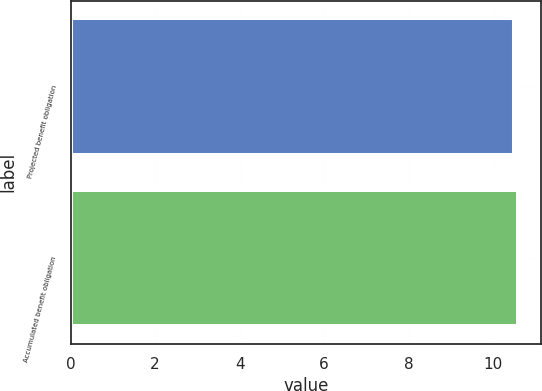Convert chart to OTSL. <chart><loc_0><loc_0><loc_500><loc_500><bar_chart><fcel>Projected benefit obligation<fcel>Accumulated benefit obligation<nl><fcel>10.5<fcel>10.6<nl></chart> 